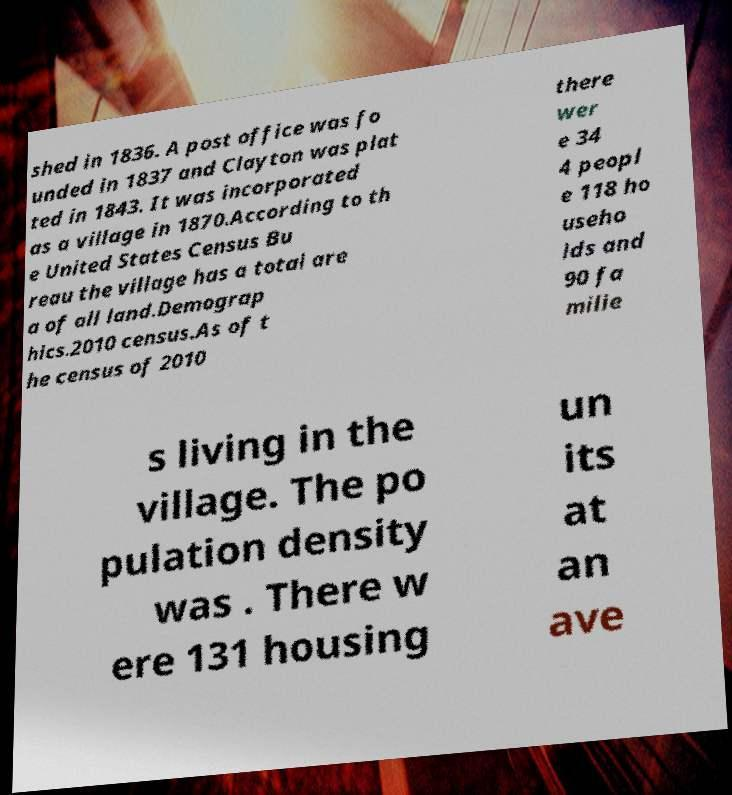For documentation purposes, I need the text within this image transcribed. Could you provide that? shed in 1836. A post office was fo unded in 1837 and Clayton was plat ted in 1843. It was incorporated as a village in 1870.According to th e United States Census Bu reau the village has a total are a of all land.Demograp hics.2010 census.As of t he census of 2010 there wer e 34 4 peopl e 118 ho useho lds and 90 fa milie s living in the village. The po pulation density was . There w ere 131 housing un its at an ave 